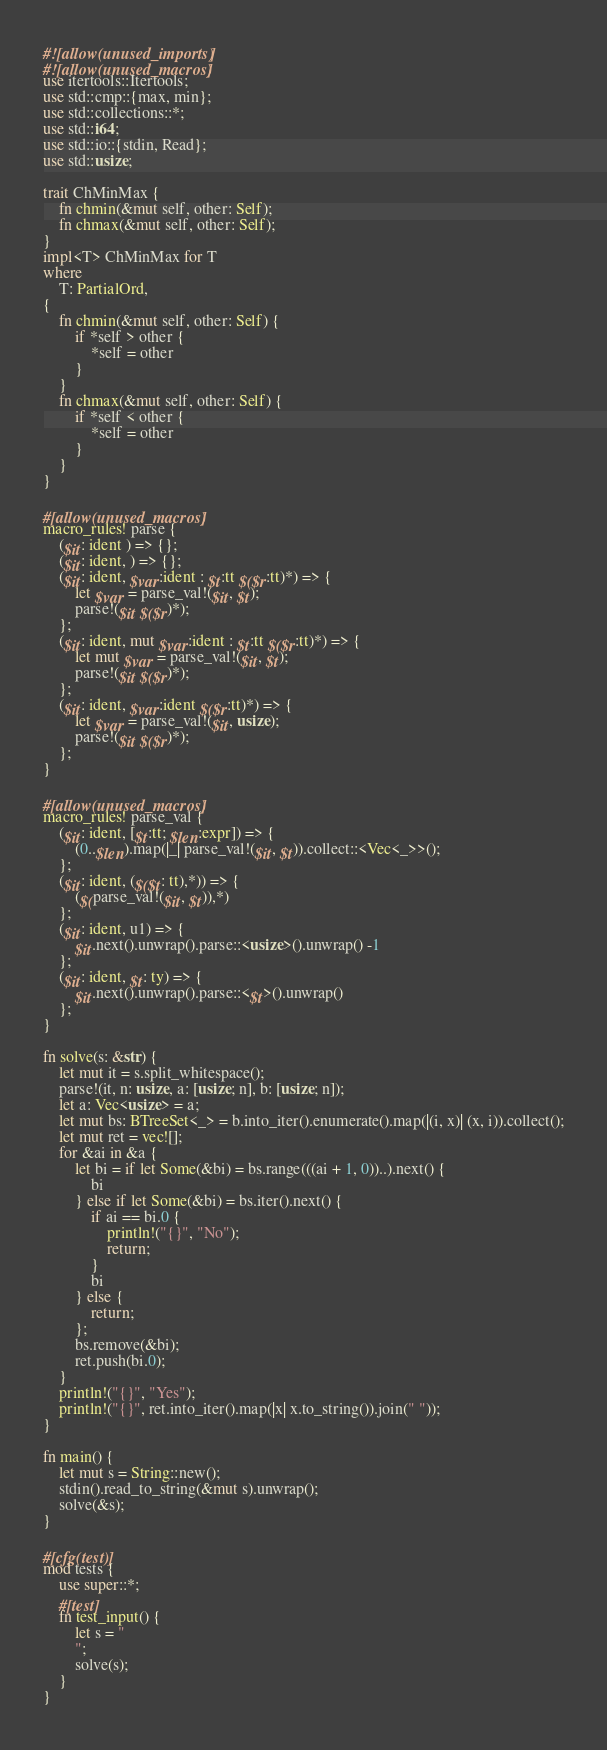<code> <loc_0><loc_0><loc_500><loc_500><_Rust_>#![allow(unused_imports)]
#![allow(unused_macros)]
use itertools::Itertools;
use std::cmp::{max, min};
use std::collections::*;
use std::i64;
use std::io::{stdin, Read};
use std::usize;

trait ChMinMax {
    fn chmin(&mut self, other: Self);
    fn chmax(&mut self, other: Self);
}
impl<T> ChMinMax for T
where
    T: PartialOrd,
{
    fn chmin(&mut self, other: Self) {
        if *self > other {
            *self = other
        }
    }
    fn chmax(&mut self, other: Self) {
        if *self < other {
            *self = other
        }
    }
}

#[allow(unused_macros)]
macro_rules! parse {
    ($it: ident ) => {};
    ($it: ident, ) => {};
    ($it: ident, $var:ident : $t:tt $($r:tt)*) => {
        let $var = parse_val!($it, $t);
        parse!($it $($r)*);
    };
    ($it: ident, mut $var:ident : $t:tt $($r:tt)*) => {
        let mut $var = parse_val!($it, $t);
        parse!($it $($r)*);
    };
    ($it: ident, $var:ident $($r:tt)*) => {
        let $var = parse_val!($it, usize);
        parse!($it $($r)*);
    };
}

#[allow(unused_macros)]
macro_rules! parse_val {
    ($it: ident, [$t:tt; $len:expr]) => {
        (0..$len).map(|_| parse_val!($it, $t)).collect::<Vec<_>>();
    };
    ($it: ident, ($($t: tt),*)) => {
        ($(parse_val!($it, $t)),*)
    };
    ($it: ident, u1) => {
        $it.next().unwrap().parse::<usize>().unwrap() -1
    };
    ($it: ident, $t: ty) => {
        $it.next().unwrap().parse::<$t>().unwrap()
    };
}

fn solve(s: &str) {
    let mut it = s.split_whitespace();
    parse!(it, n: usize, a: [usize; n], b: [usize; n]);
    let a: Vec<usize> = a;
    let mut bs: BTreeSet<_> = b.into_iter().enumerate().map(|(i, x)| (x, i)).collect();
    let mut ret = vec![];
    for &ai in &a {
        let bi = if let Some(&bi) = bs.range(((ai + 1, 0))..).next() {
            bi
        } else if let Some(&bi) = bs.iter().next() {
            if ai == bi.0 {
                println!("{}", "No");
                return;
            }
            bi
        } else {
            return;
        };
        bs.remove(&bi);
        ret.push(bi.0);
    }
    println!("{}", "Yes");
    println!("{}", ret.into_iter().map(|x| x.to_string()).join(" "));
}

fn main() {
    let mut s = String::new();
    stdin().read_to_string(&mut s).unwrap();
    solve(&s);
}

#[cfg(test)]
mod tests {
    use super::*;
    #[test]
    fn test_input() {
        let s = "
        ";
        solve(s);
    }
}
</code> 